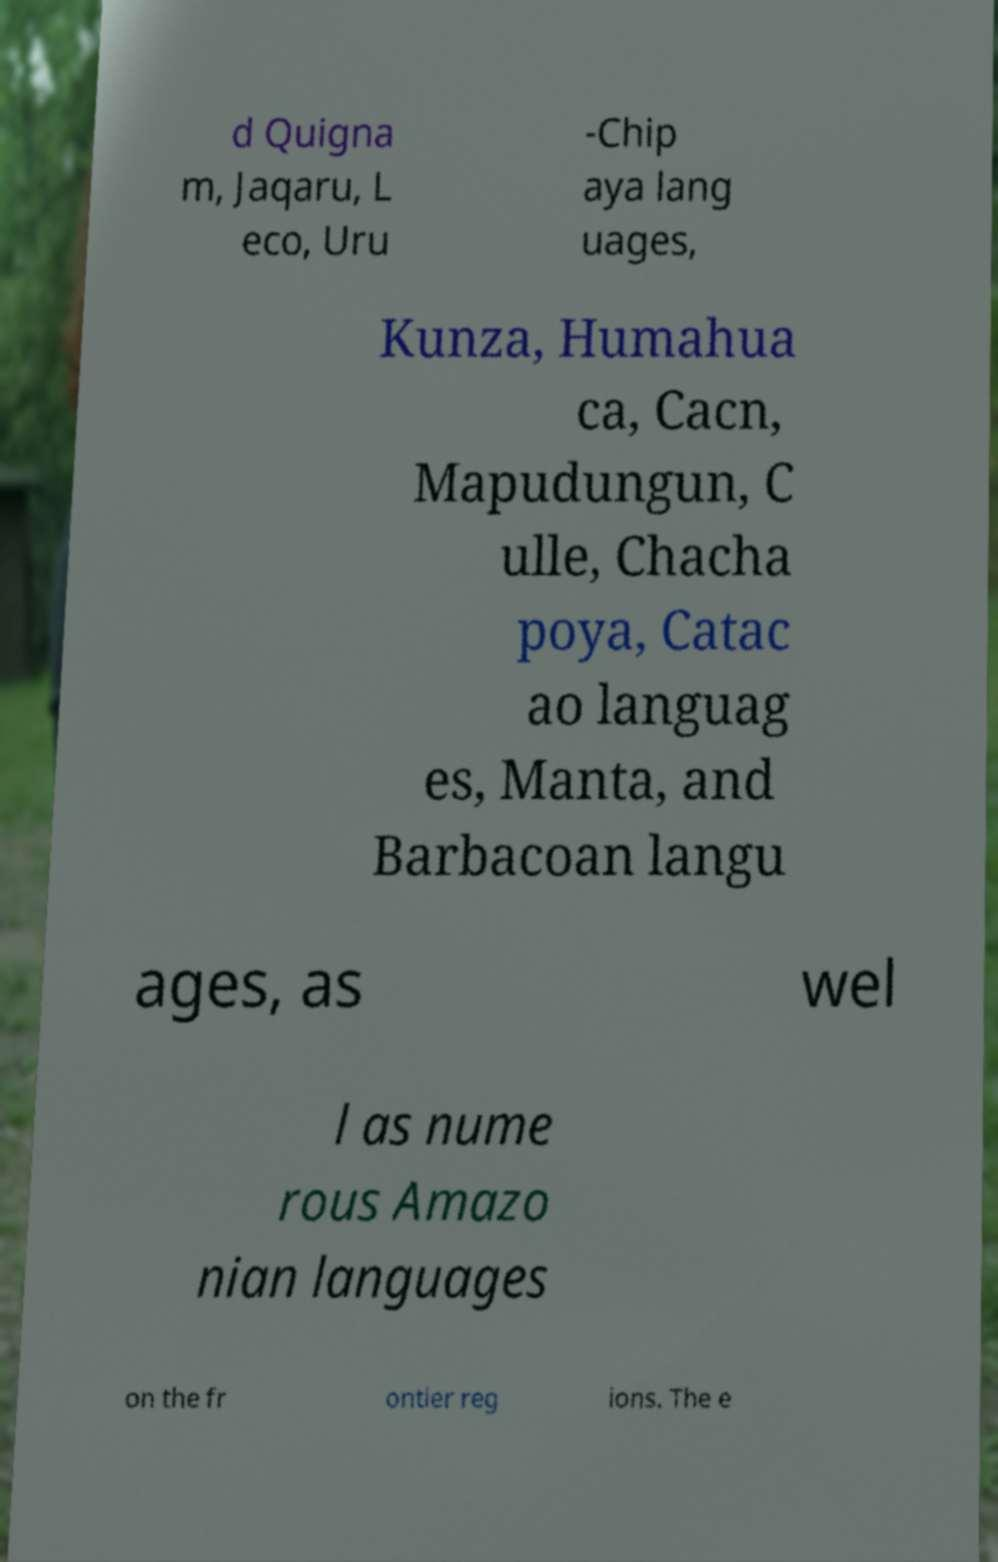There's text embedded in this image that I need extracted. Can you transcribe it verbatim? d Quigna m, Jaqaru, L eco, Uru -Chip aya lang uages, Kunza, Humahua ca, Cacn, Mapudungun, C ulle, Chacha poya, Catac ao languag es, Manta, and Barbacoan langu ages, as wel l as nume rous Amazo nian languages on the fr ontier reg ions. The e 